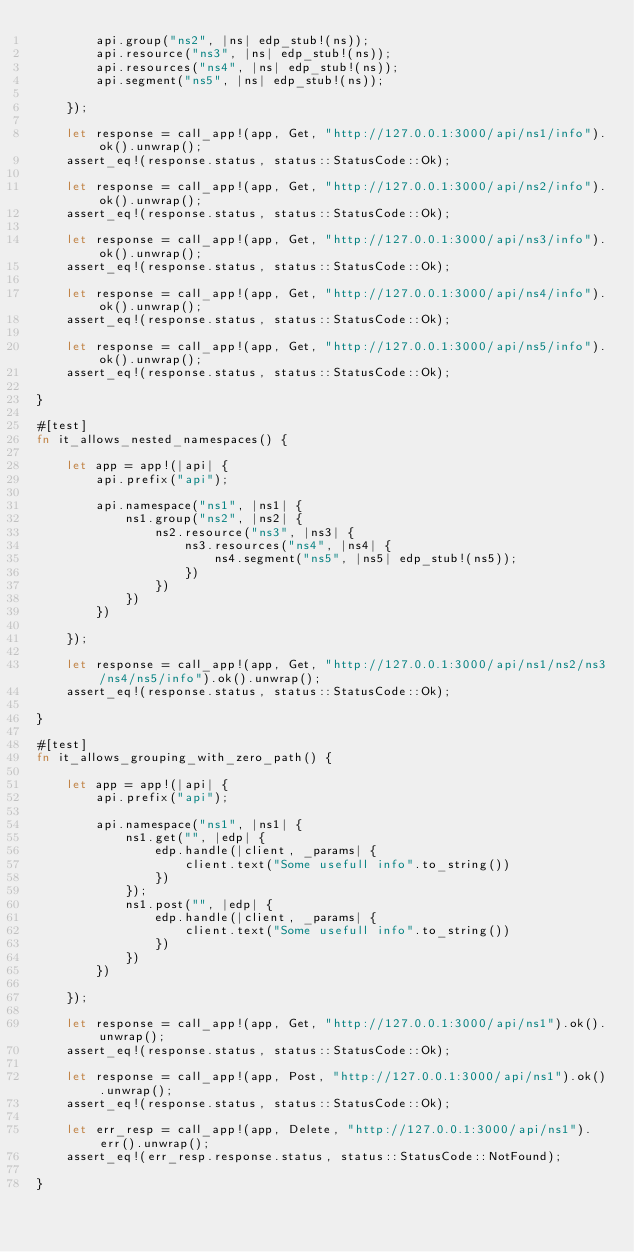Convert code to text. <code><loc_0><loc_0><loc_500><loc_500><_Rust_>        api.group("ns2", |ns| edp_stub!(ns));
        api.resource("ns3", |ns| edp_stub!(ns));
        api.resources("ns4", |ns| edp_stub!(ns));
        api.segment("ns5", |ns| edp_stub!(ns));

    });

    let response = call_app!(app, Get, "http://127.0.0.1:3000/api/ns1/info").ok().unwrap();
    assert_eq!(response.status, status::StatusCode::Ok);

    let response = call_app!(app, Get, "http://127.0.0.1:3000/api/ns2/info").ok().unwrap();
    assert_eq!(response.status, status::StatusCode::Ok);

    let response = call_app!(app, Get, "http://127.0.0.1:3000/api/ns3/info").ok().unwrap();
    assert_eq!(response.status, status::StatusCode::Ok);

    let response = call_app!(app, Get, "http://127.0.0.1:3000/api/ns4/info").ok().unwrap();
    assert_eq!(response.status, status::StatusCode::Ok);

    let response = call_app!(app, Get, "http://127.0.0.1:3000/api/ns5/info").ok().unwrap();
    assert_eq!(response.status, status::StatusCode::Ok);

}

#[test]
fn it_allows_nested_namespaces() {

    let app = app!(|api| {
        api.prefix("api");

        api.namespace("ns1", |ns1| {
            ns1.group("ns2", |ns2| {
                ns2.resource("ns3", |ns3| {
                    ns3.resources("ns4", |ns4| {
                        ns4.segment("ns5", |ns5| edp_stub!(ns5));
                    })
                })
            })
        })

    });

    let response = call_app!(app, Get, "http://127.0.0.1:3000/api/ns1/ns2/ns3/ns4/ns5/info").ok().unwrap();
    assert_eq!(response.status, status::StatusCode::Ok);

}

#[test]
fn it_allows_grouping_with_zero_path() {

    let app = app!(|api| {
        api.prefix("api");

        api.namespace("ns1", |ns1| {
            ns1.get("", |edp| {
                edp.handle(|client, _params| {
                    client.text("Some usefull info".to_string())
                })
            });
            ns1.post("", |edp| {
                edp.handle(|client, _params| {
                    client.text("Some usefull info".to_string())
                })
            })
        })

    });

    let response = call_app!(app, Get, "http://127.0.0.1:3000/api/ns1").ok().unwrap();
    assert_eq!(response.status, status::StatusCode::Ok);

    let response = call_app!(app, Post, "http://127.0.0.1:3000/api/ns1").ok().unwrap();
    assert_eq!(response.status, status::StatusCode::Ok);

    let err_resp = call_app!(app, Delete, "http://127.0.0.1:3000/api/ns1").err().unwrap();
    assert_eq!(err_resp.response.status, status::StatusCode::NotFound);

}</code> 